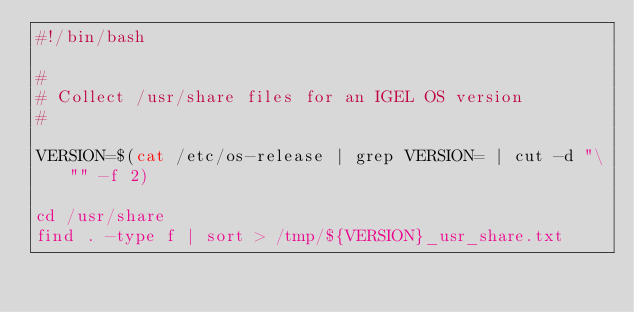Convert code to text. <code><loc_0><loc_0><loc_500><loc_500><_Bash_>#!/bin/bash

#
# Collect /usr/share files for an IGEL OS version
#

VERSION=$(cat /etc/os-release | grep VERSION= | cut -d "\"" -f 2)

cd /usr/share
find . -type f | sort > /tmp/${VERSION}_usr_share.txt
</code> 